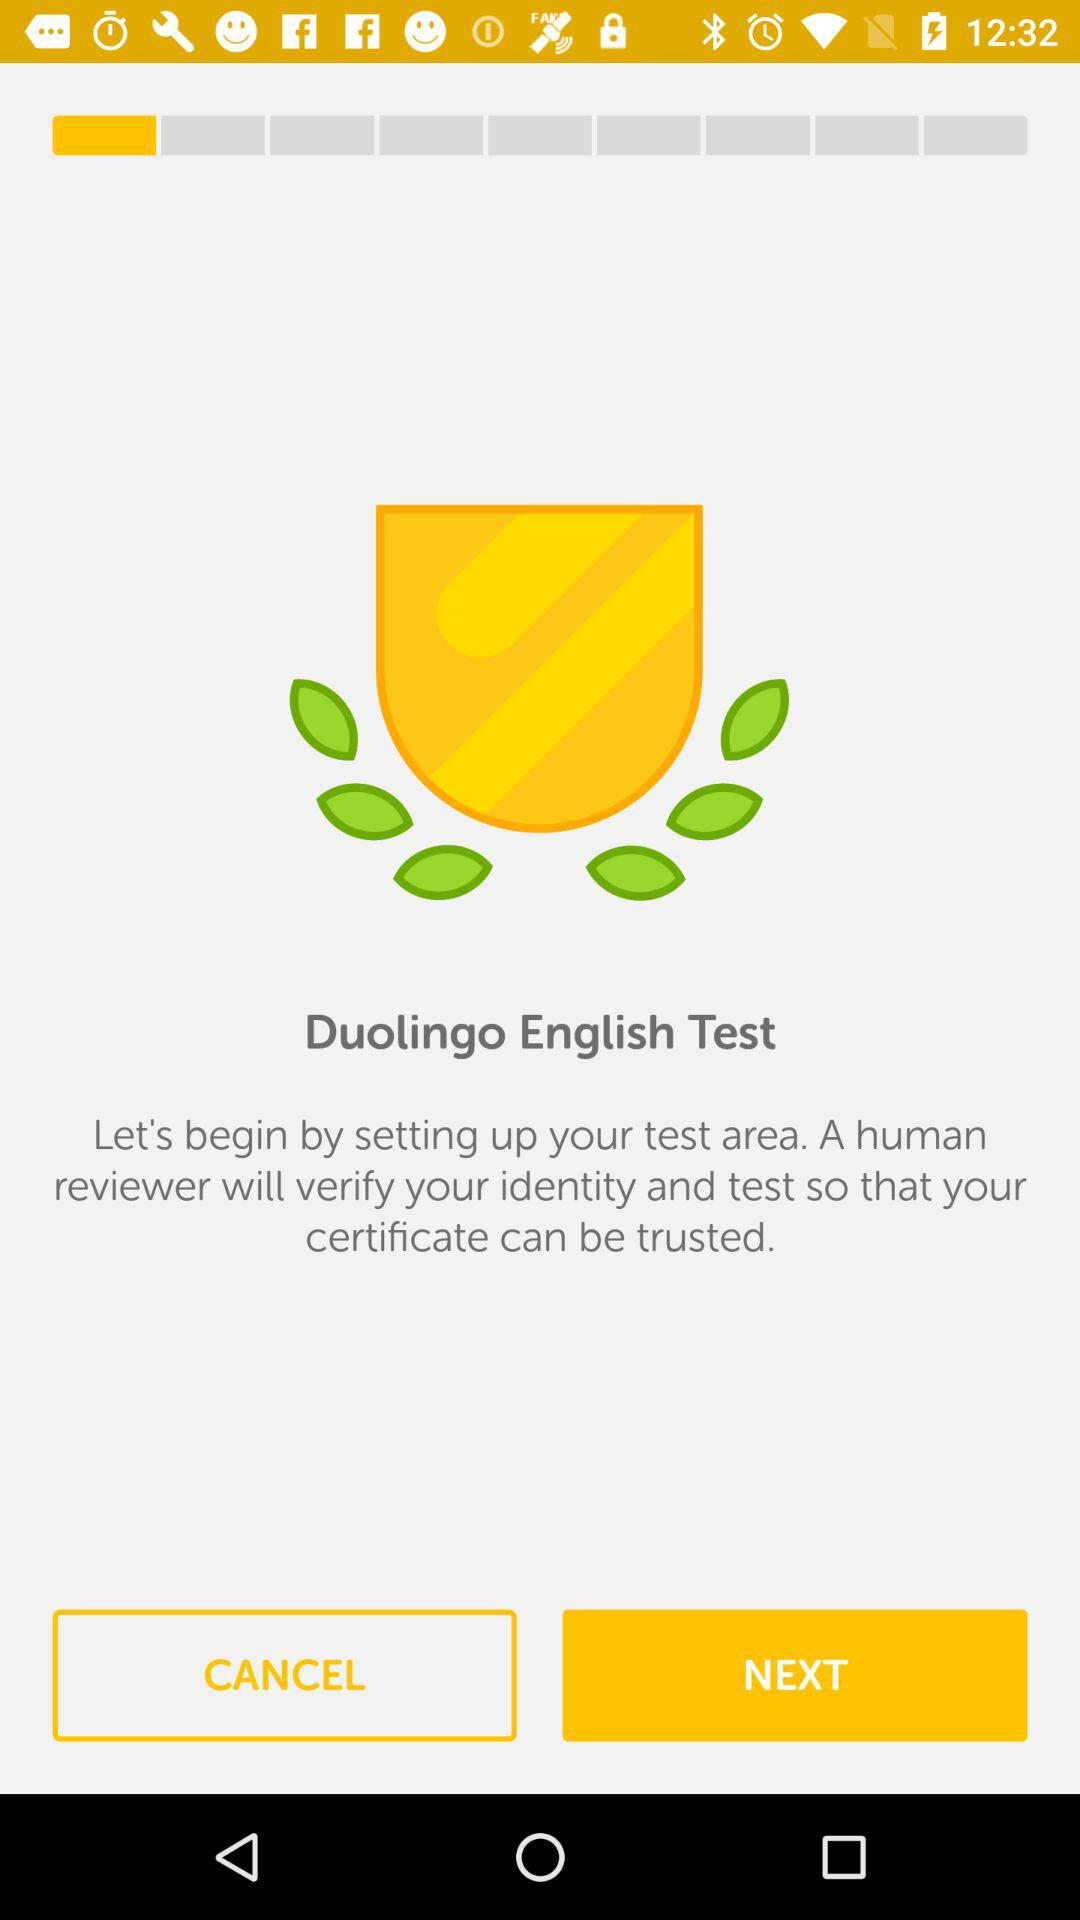Who will vouch for my credentials? Your credentials will be vouched for by a human reviewer. 